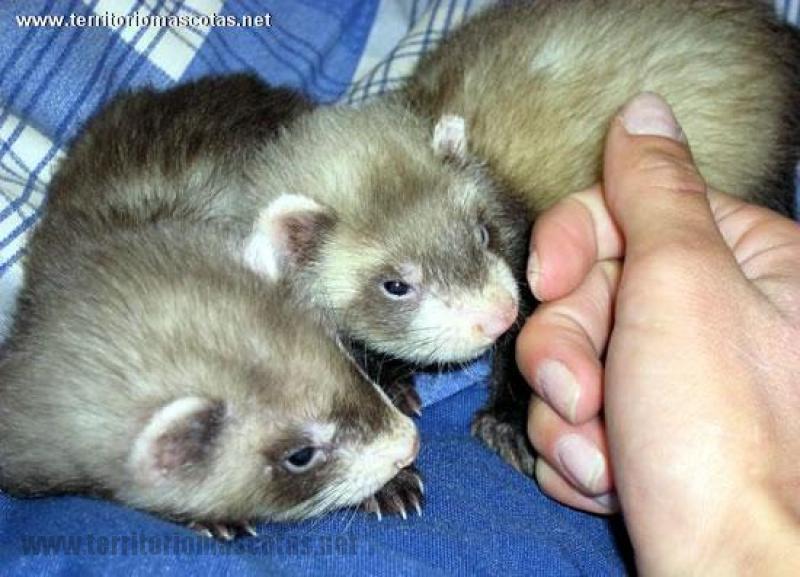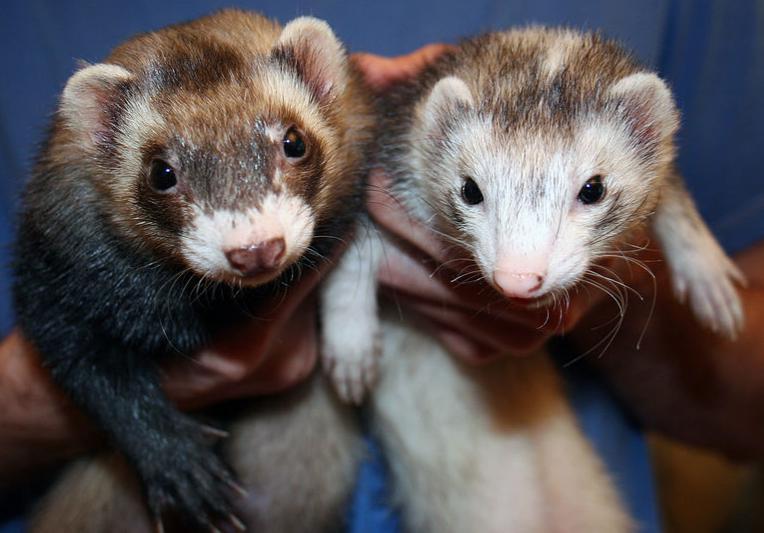The first image is the image on the left, the second image is the image on the right. Analyze the images presented: Is the assertion "Not even one of the animals appears to be awake and alert; they all seem tired, or are sleeping." valid? Answer yes or no. No. The first image is the image on the left, the second image is the image on the right. Examine the images to the left and right. Is the description "One ferret has its tongue sticking out." accurate? Answer yes or no. No. 